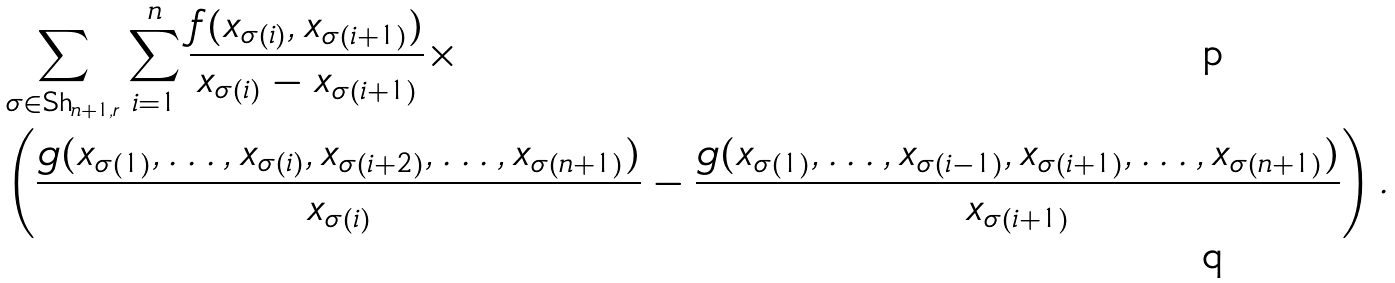Convert formula to latex. <formula><loc_0><loc_0><loc_500><loc_500>& \sum _ { \sigma \in \text {Sh} _ { n + 1 , r } } \sum _ { i = 1 } ^ { n } \frac { f ( x _ { \sigma ( i ) } , x _ { \sigma ( i + 1 ) } ) } { x _ { \sigma ( i ) } - x _ { \sigma ( i + 1 ) } } \times \\ & \left ( \frac { g ( x _ { \sigma ( 1 ) } , \dots , x _ { \sigma ( i ) } , x _ { \sigma ( i + 2 ) } , \dots , x _ { \sigma ( n + 1 ) } ) } { x _ { \sigma ( i ) } } - \frac { g ( x _ { \sigma ( 1 ) } , \dots , x _ { \sigma ( i - 1 ) } , x _ { \sigma ( i + 1 ) } , \dots , x _ { \sigma ( n + 1 ) } ) } { x _ { \sigma ( i + 1 ) } } \right ) .</formula> 